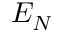Convert formula to latex. <formula><loc_0><loc_0><loc_500><loc_500>E _ { N }</formula> 